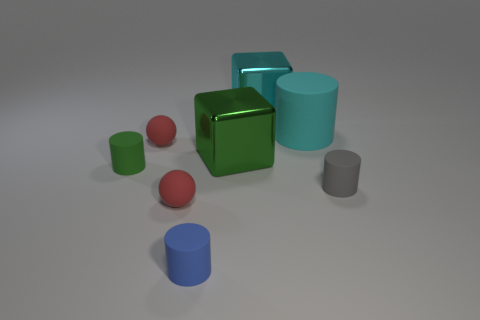Are there any tiny gray rubber cylinders behind the large cyan metal cube behind the small cylinder right of the small blue matte cylinder?
Provide a succinct answer. No. What number of blue rubber objects have the same size as the cyan cylinder?
Your answer should be very brief. 0. Does the cyan thing that is in front of the big cyan cube have the same size as the red thing in front of the small green rubber thing?
Keep it short and to the point. No. What shape is the thing that is both on the left side of the large cyan shiny cube and right of the small blue matte object?
Your answer should be compact. Cube. Are there any blocks of the same color as the large rubber cylinder?
Your answer should be compact. Yes. Are there any small red matte things?
Keep it short and to the point. Yes. There is a matte cylinder on the right side of the large cyan matte thing; what color is it?
Give a very brief answer. Gray. There is a cyan cylinder; does it have the same size as the matte ball in front of the green block?
Your answer should be very brief. No. How big is the cylinder that is both right of the tiny blue cylinder and in front of the cyan rubber cylinder?
Make the answer very short. Small. Are there any small gray cylinders that have the same material as the blue thing?
Make the answer very short. Yes. 